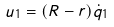Convert formula to latex. <formula><loc_0><loc_0><loc_500><loc_500>u _ { 1 } = ( R - r ) \dot { q } _ { 1 }</formula> 